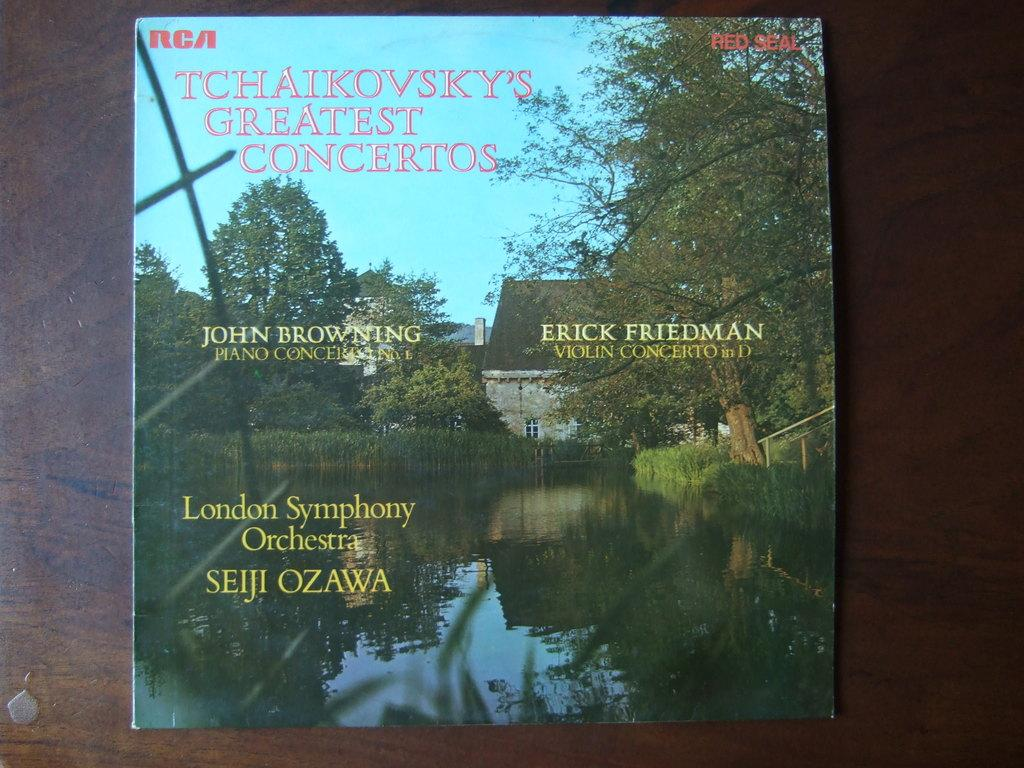<image>
Describe the image concisely. The album cover for "Tchaikovsky's Greatest Concertos" sits on a wooden table. 